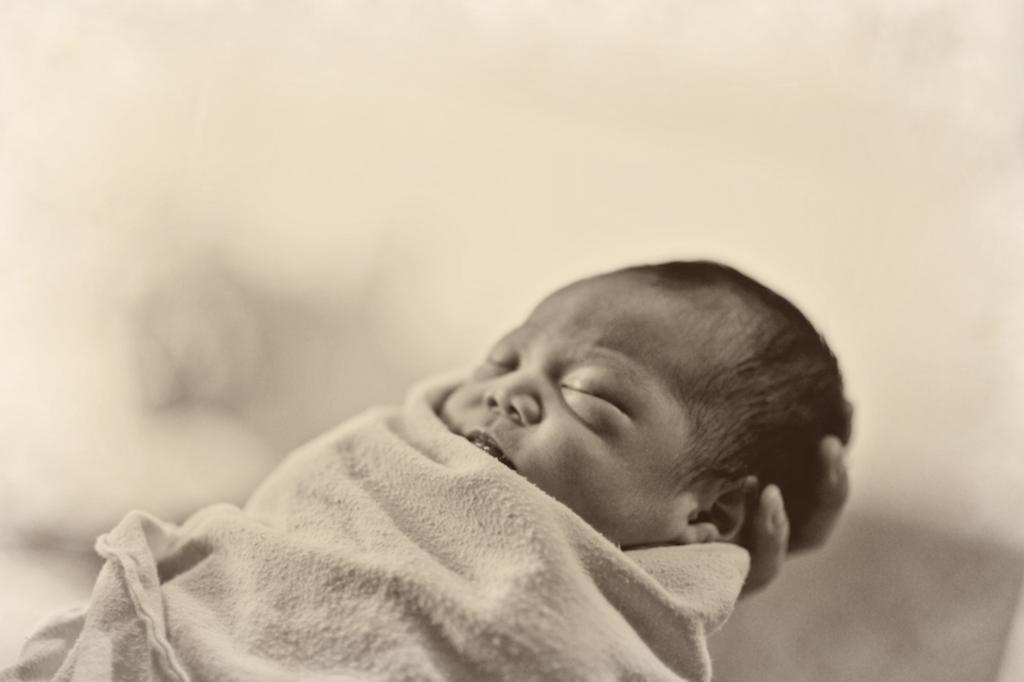Could you give a brief overview of what you see in this image? In this picture there is a baby on person's hand. In the background of the image it is blurry. 